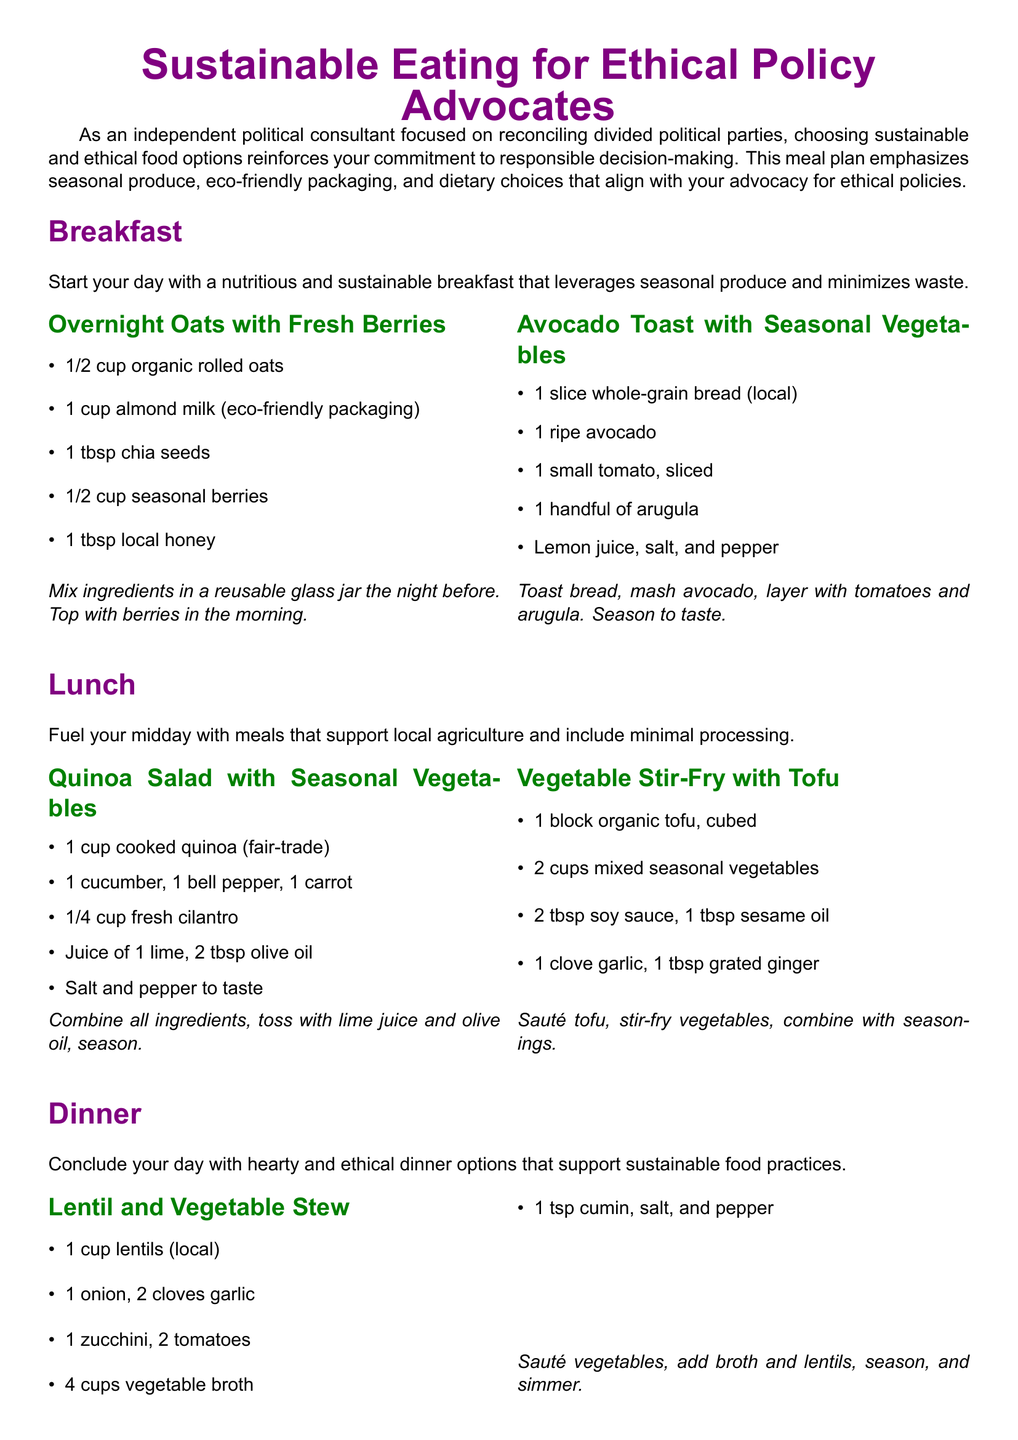What is the title of the meal plan? The title is listed at the beginning of the document and highlights the focus on sustainable eating.
Answer: Sustainable Eating for Ethical Policy Advocates How many breakfast options are provided? The breakfast section lists two distinct meal options presented under individual headings.
Answer: 2 What type of milk is used in the Overnight Oats? The specific milk type suitable for the meal choice is mentioned in the overnight oats recipe description.
Answer: Almond milk Which protein source is used in the Vegetable Stir-Fry? The protein source is highlighted in the ingredients list for the stir-fry recipe, emphasizing plant-based options.
Answer: Tofu What is one eco-friendly packaging tip mentioned? The document provides a list of suggestions, and one specific tip is highlighted in the eco-friendly packaging tips section.
Answer: Use reusable containers What meal uses black beans as an ingredient? This ingredient is explicitly stated in the recipe for one of the dinner options that features these legumes prominently.
Answer: Stuffed Bell Peppers What is one connection to policy-making discussed? The document connects dietary choices to policy advocacy and offers specific recommendations for ethical policies.
Answer: Advocate for local and organic farming policies How long should the Stuffed Bell Peppers be baked? The baking time for this dish is clearly outlined within the cooking instructions section.
Answer: 25 minutes 